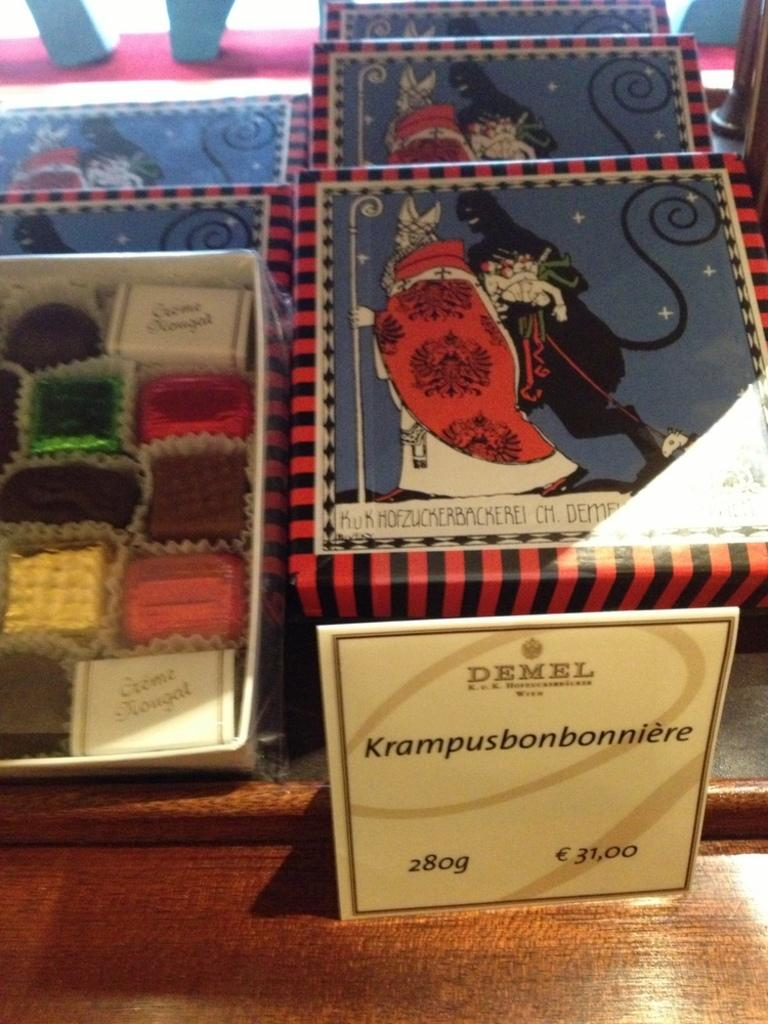<image>
Write a terse but informative summary of the picture. the word Krampus is on the white item on the table 